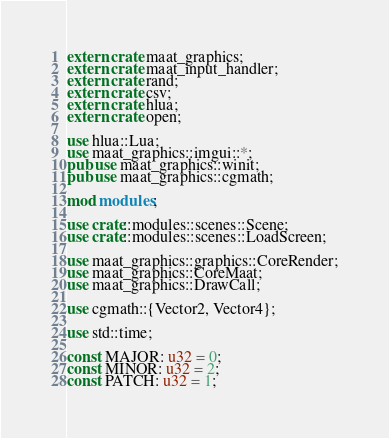<code> <loc_0><loc_0><loc_500><loc_500><_Rust_>extern crate maat_graphics;
extern crate maat_input_handler;
extern crate rand;
extern crate csv;
extern crate hlua;
extern crate open;

use hlua::Lua;
use maat_graphics::imgui::*;
pub use maat_graphics::winit;
pub use maat_graphics::cgmath;

mod modules;

use crate::modules::scenes::Scene;
use crate::modules::scenes::LoadScreen;

use maat_graphics::graphics::CoreRender;
use maat_graphics::CoreMaat;
use maat_graphics::DrawCall;

use cgmath::{Vector2, Vector4};

use std::time;

const MAJOR: u32 = 0;
const MINOR: u32 = 2;
const PATCH: u32 = 1;
</code> 